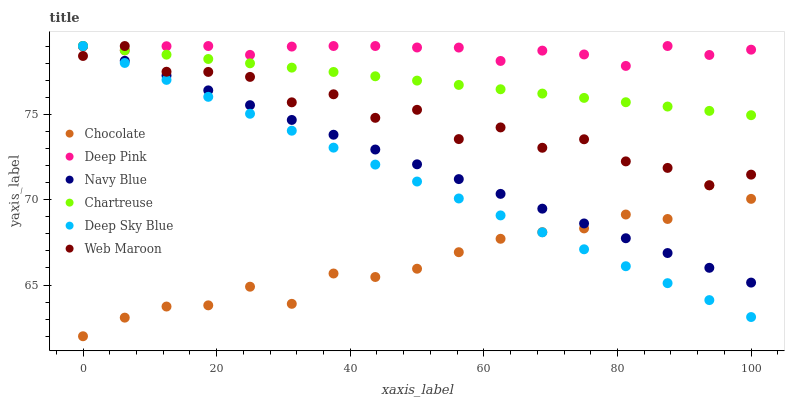Does Chocolate have the minimum area under the curve?
Answer yes or no. Yes. Does Deep Pink have the maximum area under the curve?
Answer yes or no. Yes. Does Navy Blue have the minimum area under the curve?
Answer yes or no. No. Does Navy Blue have the maximum area under the curve?
Answer yes or no. No. Is Deep Sky Blue the smoothest?
Answer yes or no. Yes. Is Web Maroon the roughest?
Answer yes or no. Yes. Is Navy Blue the smoothest?
Answer yes or no. No. Is Navy Blue the roughest?
Answer yes or no. No. Does Chocolate have the lowest value?
Answer yes or no. Yes. Does Navy Blue have the lowest value?
Answer yes or no. No. Does Deep Sky Blue have the highest value?
Answer yes or no. Yes. Does Chocolate have the highest value?
Answer yes or no. No. Is Chocolate less than Chartreuse?
Answer yes or no. Yes. Is Deep Pink greater than Chocolate?
Answer yes or no. Yes. Does Navy Blue intersect Chocolate?
Answer yes or no. Yes. Is Navy Blue less than Chocolate?
Answer yes or no. No. Is Navy Blue greater than Chocolate?
Answer yes or no. No. Does Chocolate intersect Chartreuse?
Answer yes or no. No. 